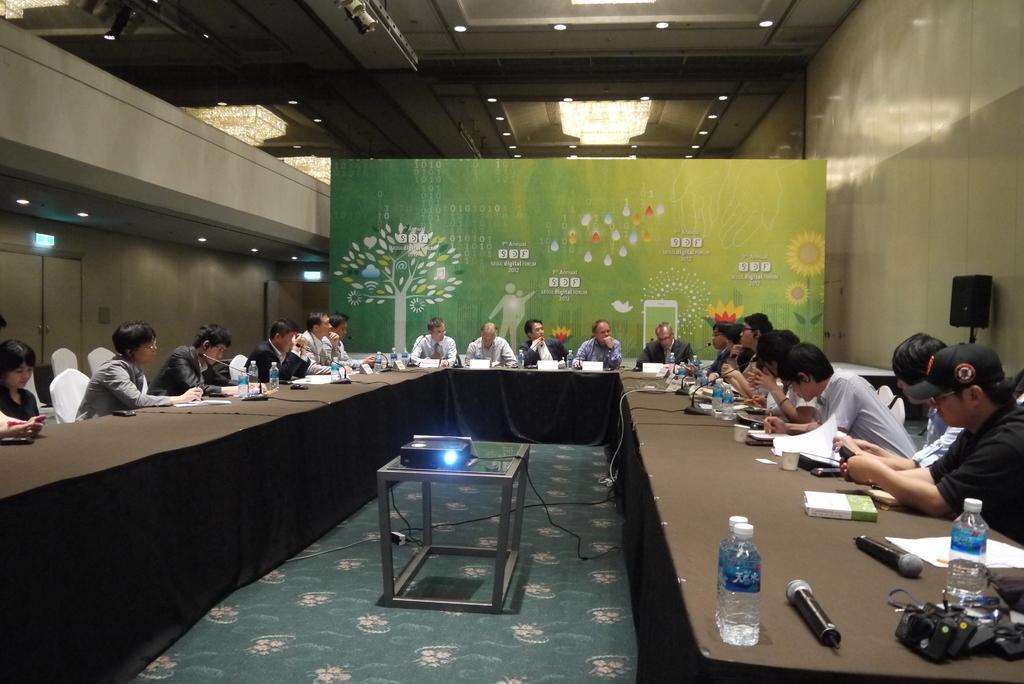Could you give a brief overview of what you see in this image? In the image I can see some people sitting in front of the table on which there are some mics, bottles, books and some other things and also I can see a projector screen and some lights to the roof. 